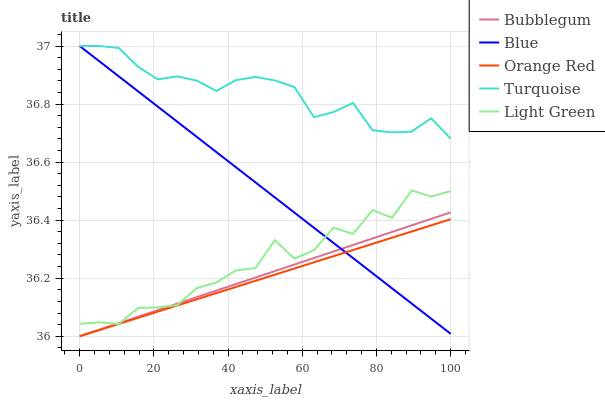Does Orange Red have the minimum area under the curve?
Answer yes or no. Yes. Does Turquoise have the maximum area under the curve?
Answer yes or no. Yes. Does Light Green have the minimum area under the curve?
Answer yes or no. No. Does Light Green have the maximum area under the curve?
Answer yes or no. No. Is Blue the smoothest?
Answer yes or no. Yes. Is Light Green the roughest?
Answer yes or no. Yes. Is Turquoise the smoothest?
Answer yes or no. No. Is Turquoise the roughest?
Answer yes or no. No. Does Orange Red have the lowest value?
Answer yes or no. Yes. Does Light Green have the lowest value?
Answer yes or no. No. Does Turquoise have the highest value?
Answer yes or no. Yes. Does Light Green have the highest value?
Answer yes or no. No. Is Light Green less than Turquoise?
Answer yes or no. Yes. Is Turquoise greater than Bubblegum?
Answer yes or no. Yes. Does Bubblegum intersect Light Green?
Answer yes or no. Yes. Is Bubblegum less than Light Green?
Answer yes or no. No. Is Bubblegum greater than Light Green?
Answer yes or no. No. Does Light Green intersect Turquoise?
Answer yes or no. No. 